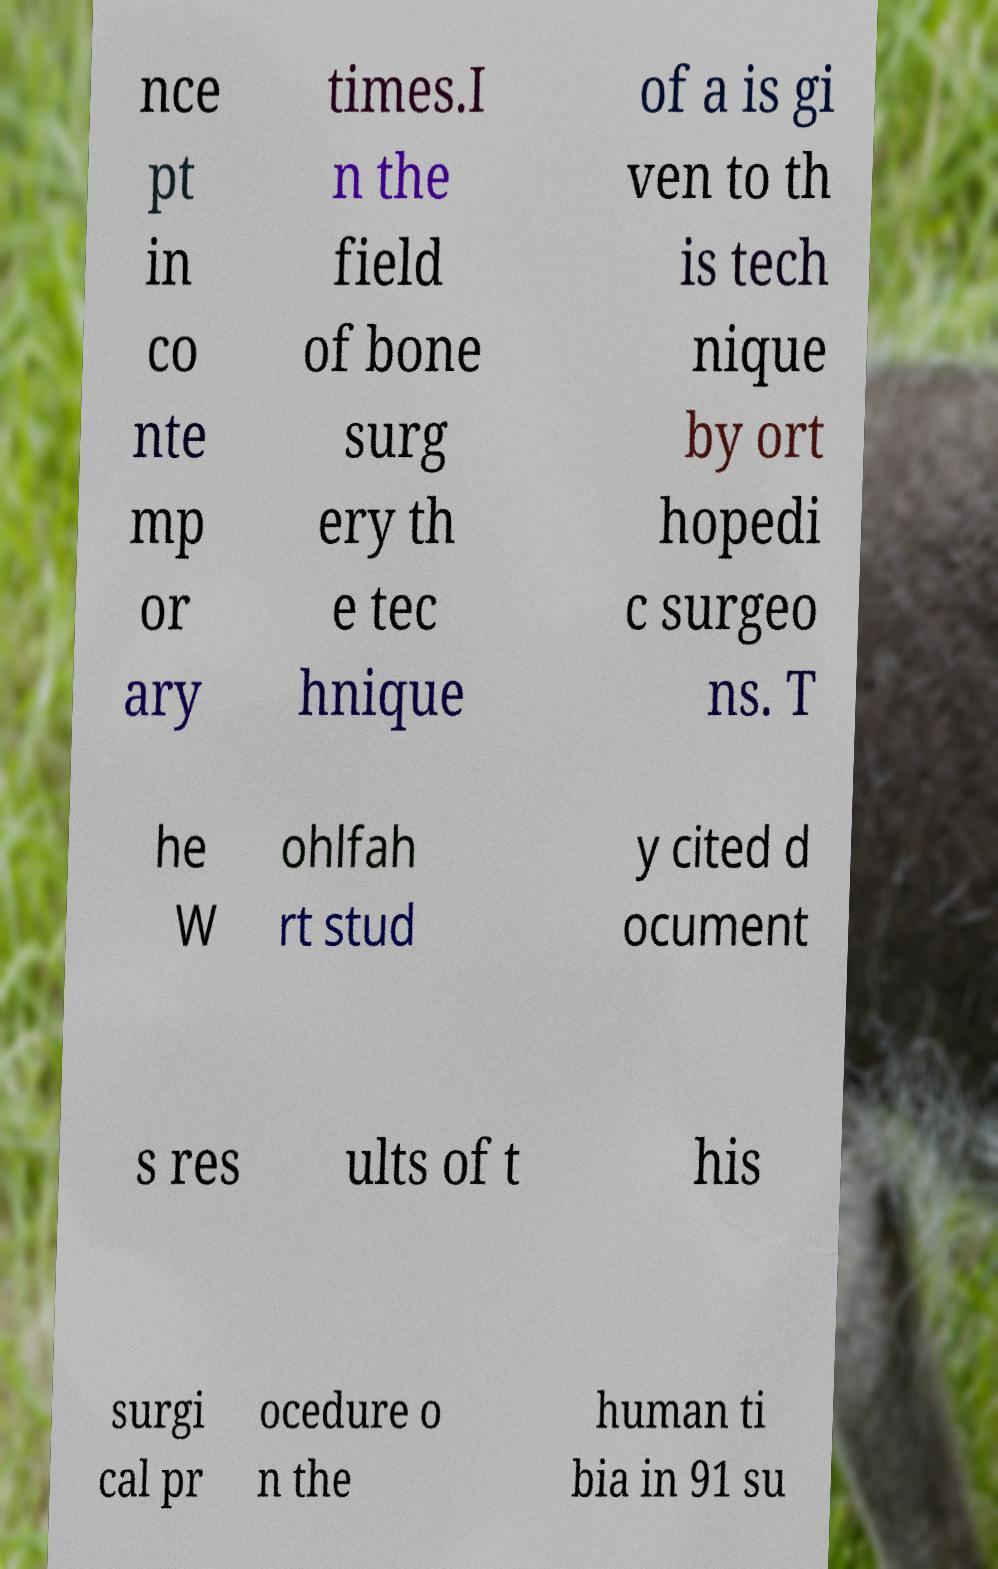I need the written content from this picture converted into text. Can you do that? nce pt in co nte mp or ary times.I n the field of bone surg ery th e tec hnique of a is gi ven to th is tech nique by ort hopedi c surgeo ns. T he W ohlfah rt stud y cited d ocument s res ults of t his surgi cal pr ocedure o n the human ti bia in 91 su 